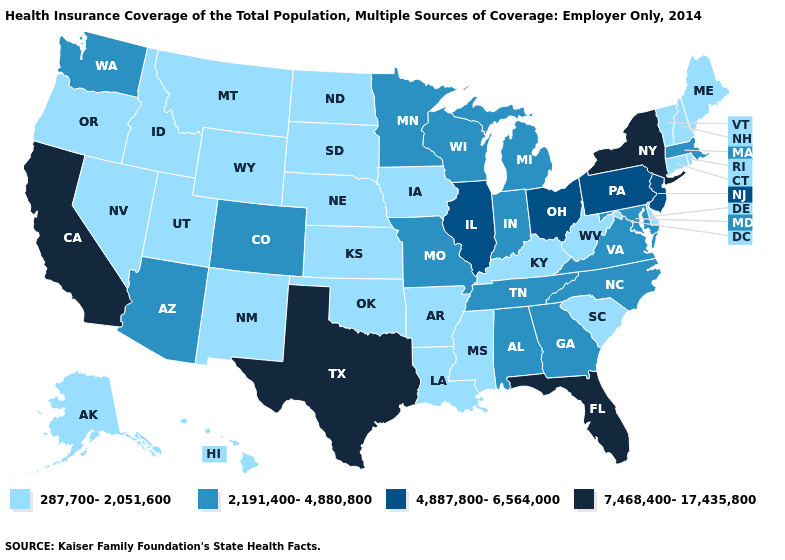Does California have the highest value in the USA?
Be succinct. Yes. Does Minnesota have a lower value than South Dakota?
Keep it brief. No. Does Vermont have the same value as Pennsylvania?
Be succinct. No. What is the value of Louisiana?
Be succinct. 287,700-2,051,600. Among the states that border New Mexico , which have the highest value?
Keep it brief. Texas. Which states hav the highest value in the West?
Write a very short answer. California. Is the legend a continuous bar?
Concise answer only. No. Name the states that have a value in the range 7,468,400-17,435,800?
Concise answer only. California, Florida, New York, Texas. What is the value of Michigan?
Keep it brief. 2,191,400-4,880,800. What is the value of California?
Write a very short answer. 7,468,400-17,435,800. What is the value of New Jersey?
Write a very short answer. 4,887,800-6,564,000. Name the states that have a value in the range 4,887,800-6,564,000?
Keep it brief. Illinois, New Jersey, Ohio, Pennsylvania. Among the states that border Wisconsin , which have the lowest value?
Write a very short answer. Iowa. Among the states that border Wisconsin , does Iowa have the highest value?
Short answer required. No. Which states have the highest value in the USA?
Give a very brief answer. California, Florida, New York, Texas. 